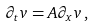<formula> <loc_0><loc_0><loc_500><loc_500>\partial _ { t } v = A \partial _ { x } v \, ,</formula> 